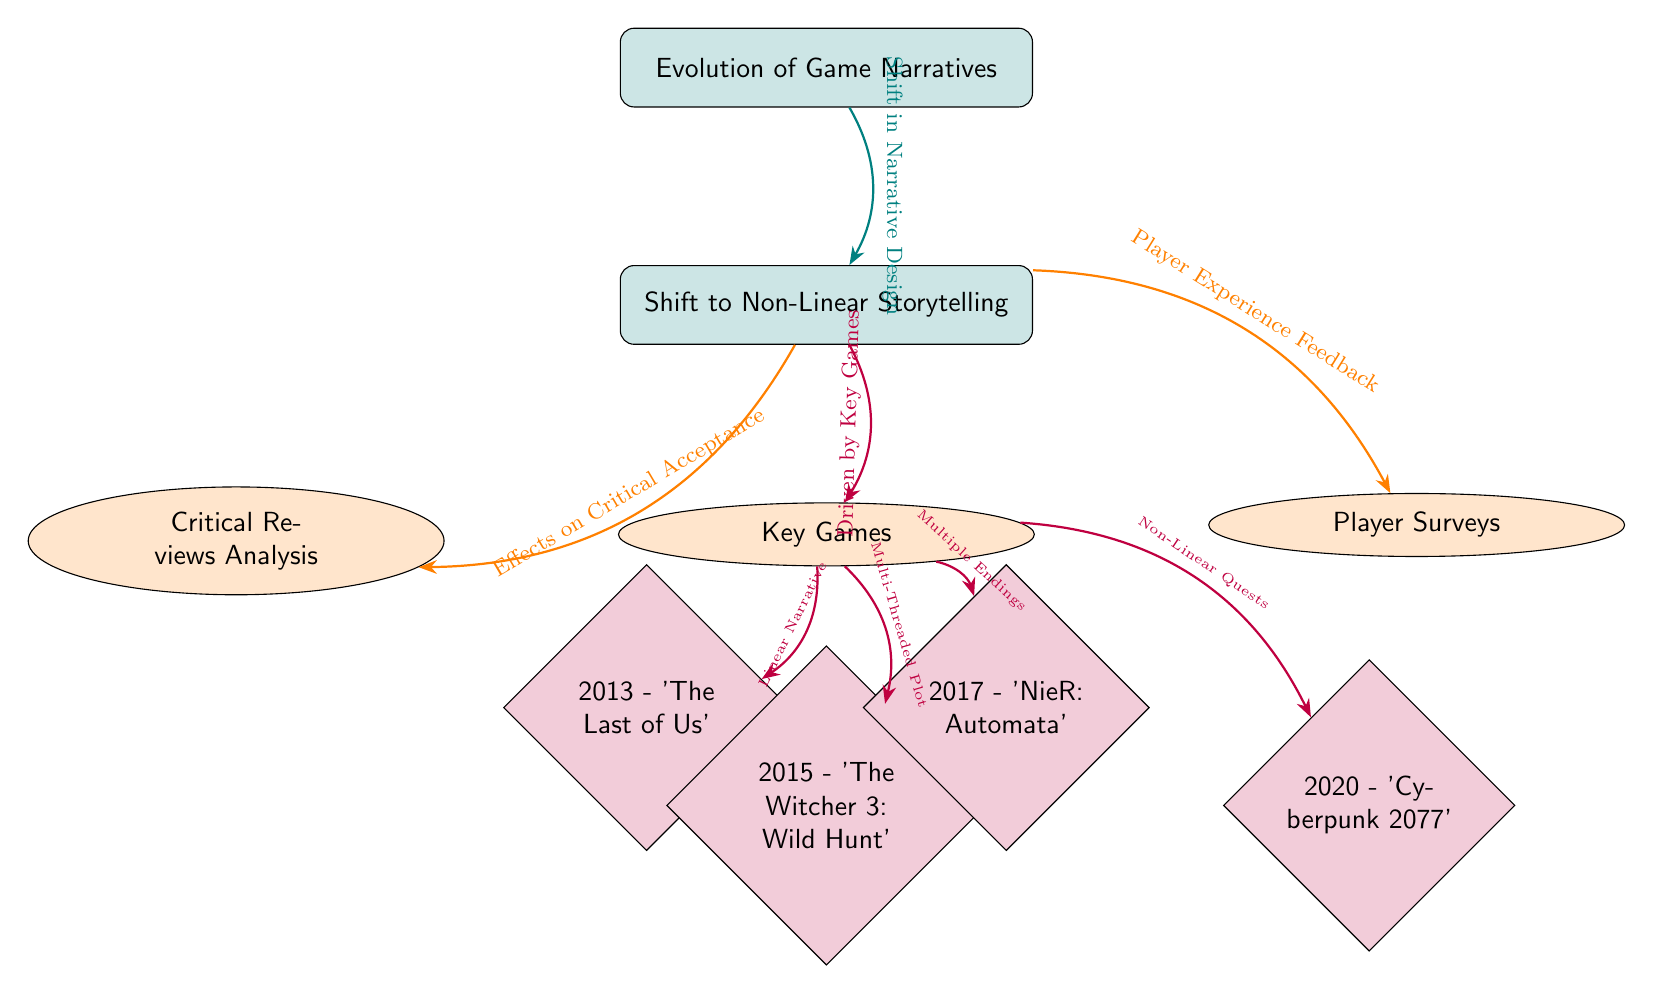What is the main theme of the diagram? The main theme is the "Evolution of Game Narratives," which is represented at the top of the diagram as the primary node connecting to other nodes. This central focus leads to the examination of non-linear storytelling in games.
Answer: Evolution of Game Narratives How many key games are identified in the diagram? The diagram shows a total of four key games listed below the key games node, showcasing specific titles that demonstrate the evolution of narrative design.
Answer: 4 What connects non-linear storytelling to critical reviews? The diagram illustrates the connection between non-linear storytelling and critical reviews through an arrow labeled "Effects on Critical Acceptance," indicating that the shift to non-linear storytelling impacts how games are received by critics.
Answer: Effects on Critical Acceptance Which game is associated with a linear narrative? The diagram links the game "The Last of Us" to the key games, indicating that it represents a linear narrative within the context of evolving storytelling structures.
Answer: The Last of Us What kind of narrative structure is associated with "The Witcher 3: Wild Hunt"? The arrow leading from the key games node to "The Witcher 3: Wild Hunt" is labeled "Multi-Threaded Plot," indicating that this game utilizes a more complex narrative structure compared to linear storytelling.
Answer: Multi-Threaded Plot What factor is indicated to drive the shift to non-linear storytelling? The diagram connects the shift to non-linear storytelling with the node labeled "Driven by Key Games," suggesting that the development and popularity of certain influential games are significant factors in this evolution.
Answer: Driven by Key Games How does player feedback relate to non-linear storytelling? The diagram includes the connection labeled "Player Experience Feedback," which links player surveys to non-linear storytelling, indicating that players’ responses have influenced the recognition and implementation of non-linear narrative designs.
Answer: Player Experience Feedback What is the relationship between key games and their narrative structures? The diagram shows that each of the four listed games is tied to a specific narrative structure, with distinct labels (such as "Linear Narrative" for The Last of Us and "Multiple Endings" for NieR: Automata) connecting them. This reflects the diversity in narrative approaches that emerged from key games.
Answer: Different narrative structures per game 